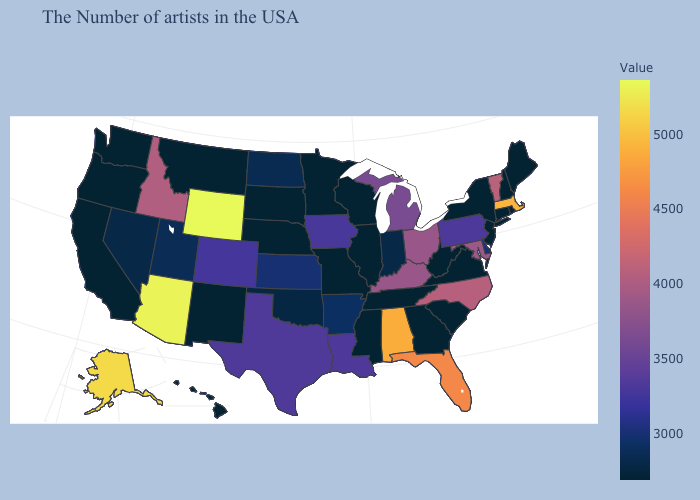Among the states that border Wisconsin , which have the highest value?
Concise answer only. Michigan. Which states hav the highest value in the MidWest?
Write a very short answer. Ohio. Which states have the highest value in the USA?
Quick response, please. Wyoming. Does Wyoming have the highest value in the West?
Be succinct. Yes. Among the states that border Wyoming , does Montana have the lowest value?
Short answer required. Yes. Among the states that border Maine , which have the highest value?
Write a very short answer. New Hampshire. Among the states that border Missouri , does Nebraska have the lowest value?
Keep it brief. Yes. 